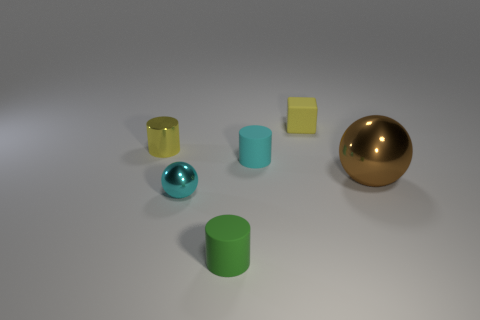Subtract all rubber cylinders. How many cylinders are left? 1 Add 4 small cyan matte cylinders. How many objects exist? 10 Subtract 1 cylinders. How many cylinders are left? 2 Subtract all blocks. How many objects are left? 5 Subtract all yellow cylinders. How many cylinders are left? 2 Subtract all blue balls. Subtract all brown cylinders. How many balls are left? 2 Subtract all small cyan shiny objects. Subtract all yellow cylinders. How many objects are left? 4 Add 5 large brown shiny objects. How many large brown shiny objects are left? 6 Add 4 yellow things. How many yellow things exist? 6 Subtract 0 brown cubes. How many objects are left? 6 